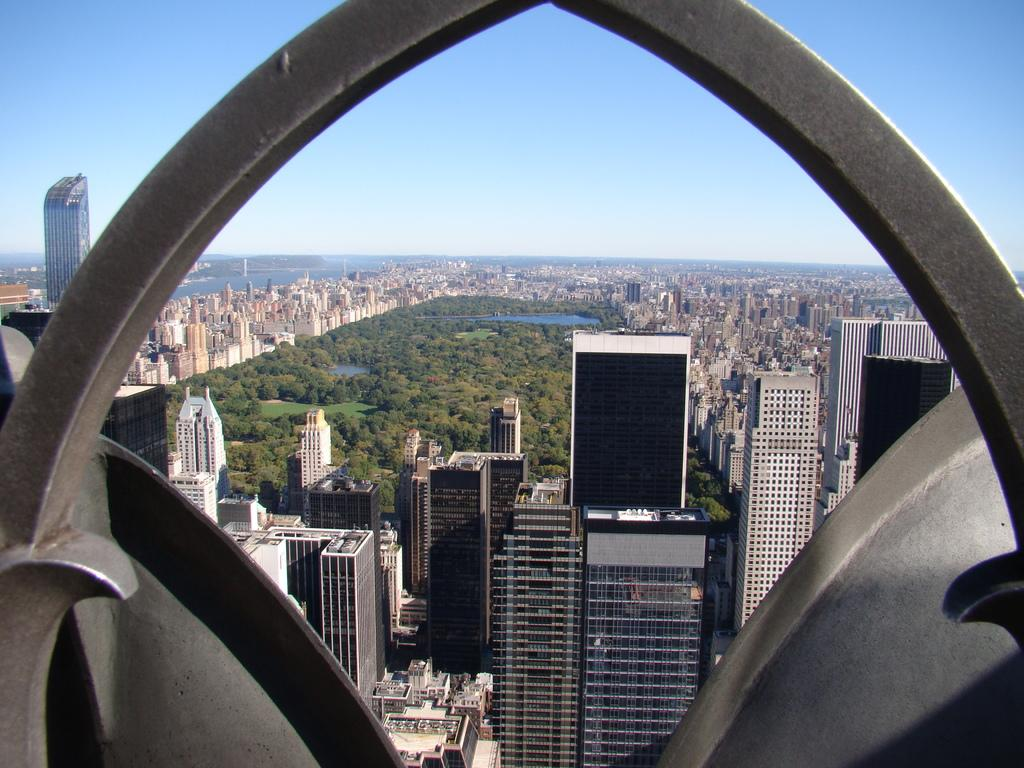What type of structure is present in the image? There is an arch in the image. What else can be seen in the image besides the arch? There are buildings and trees visible in the image. Is there any water visible in the image? Yes, there is water visible in the image. What is visible in the background of the image? The sky is visible in the background of the image. What type of mitten is being used to maintain peace in the image? There is no mitten or reference to peace in the image; it features an arch, buildings, trees, water, and the sky. 